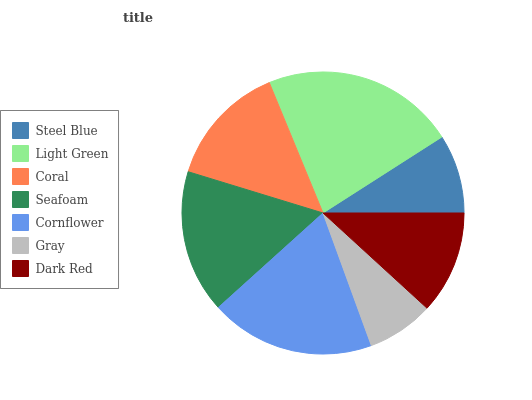Is Gray the minimum?
Answer yes or no. Yes. Is Light Green the maximum?
Answer yes or no. Yes. Is Coral the minimum?
Answer yes or no. No. Is Coral the maximum?
Answer yes or no. No. Is Light Green greater than Coral?
Answer yes or no. Yes. Is Coral less than Light Green?
Answer yes or no. Yes. Is Coral greater than Light Green?
Answer yes or no. No. Is Light Green less than Coral?
Answer yes or no. No. Is Coral the high median?
Answer yes or no. Yes. Is Coral the low median?
Answer yes or no. Yes. Is Cornflower the high median?
Answer yes or no. No. Is Seafoam the low median?
Answer yes or no. No. 